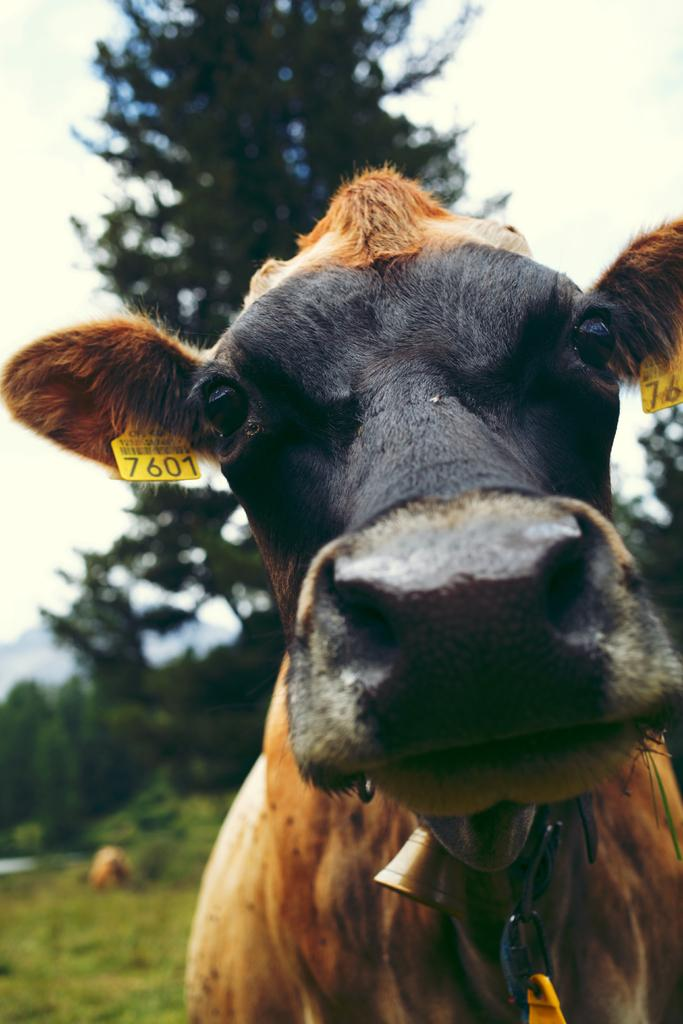What animal is present in the image? There is a cow in the image. What can be seen in the background of the image? There are trees, plants, mountains, and grass in the background of the image. Where is the sky visible in the image? The sky is visible at the top right of the image. What type of vessel is being used to cook the stew in the image? There is no vessel or stew present in the image; it features a cow and various background elements. 